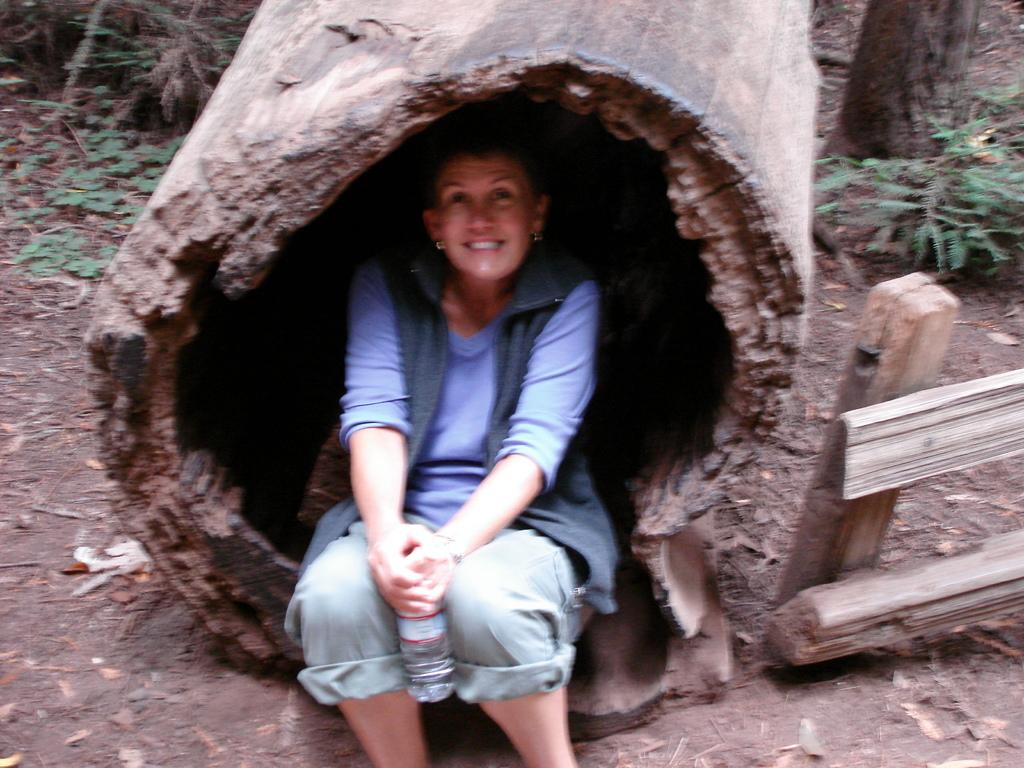Who is present in the image? There is a woman in the image. What is the woman doing in the image? The woman is sitting in a bark. What type of clothing is the woman wearing? The woman is wearing a t-shirt, trousers, and a coat. What is the woman's facial expression in the image? The woman is smiling. What can be seen on the right side of the image? There is a wooden frame on the right side of the image. Are there any fairies visible in the image? No, there are no fairies present in the image. What type of tray is the woman using to hold her belongings in the image? There is no tray visible in the image. 